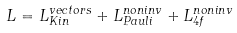<formula> <loc_0><loc_0><loc_500><loc_500>L = L _ { K i n } ^ { v e c t o r s } + L _ { P a u l i } ^ { n o n i n v } + L _ { 4 f } ^ { n o n i n v }</formula> 